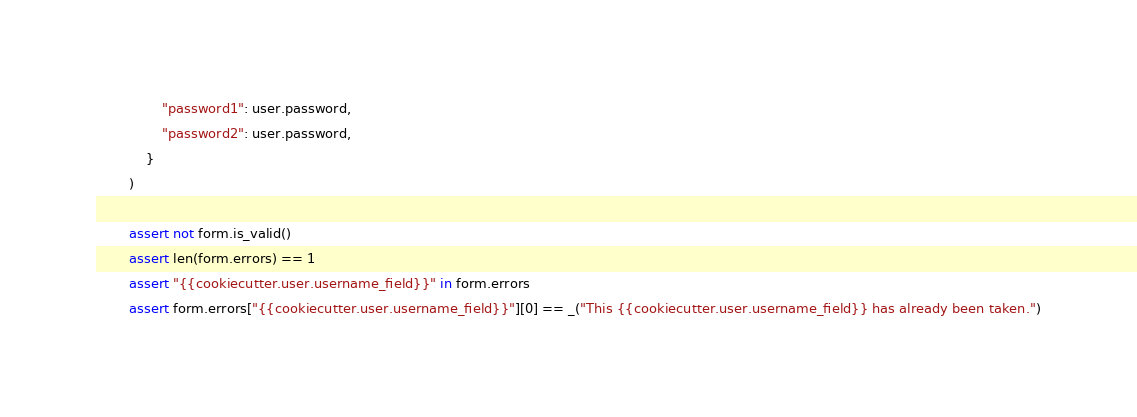Convert code to text. <code><loc_0><loc_0><loc_500><loc_500><_Python_>                "password1": user.password,
                "password2": user.password,
            }
        )

        assert not form.is_valid()
        assert len(form.errors) == 1
        assert "{{cookiecutter.user.username_field}}" in form.errors
        assert form.errors["{{cookiecutter.user.username_field}}"][0] == _("This {{cookiecutter.user.username_field}} has already been taken.")
</code> 